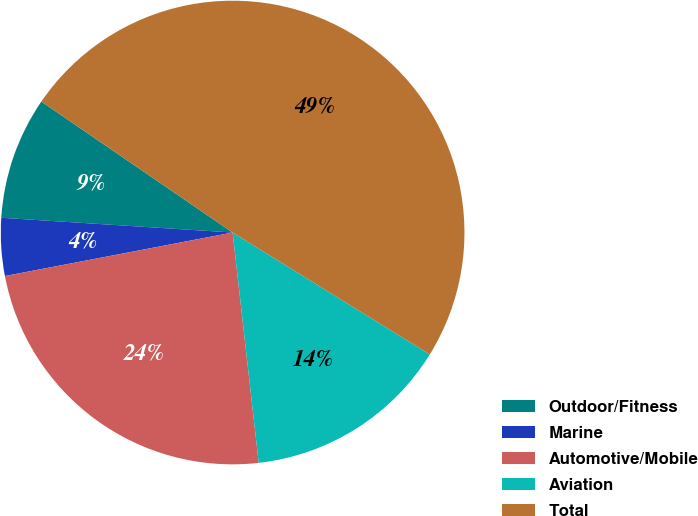Convert chart to OTSL. <chart><loc_0><loc_0><loc_500><loc_500><pie_chart><fcel>Outdoor/Fitness<fcel>Marine<fcel>Automotive/Mobile<fcel>Aviation<fcel>Total<nl><fcel>8.54%<fcel>4.02%<fcel>23.79%<fcel>14.39%<fcel>49.26%<nl></chart> 